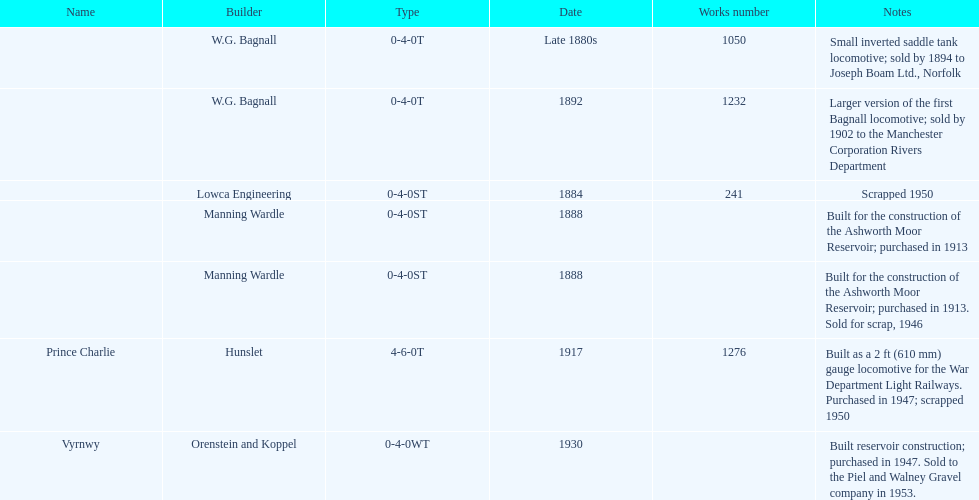How many steam locomotives were created before the 1900s? 5. 